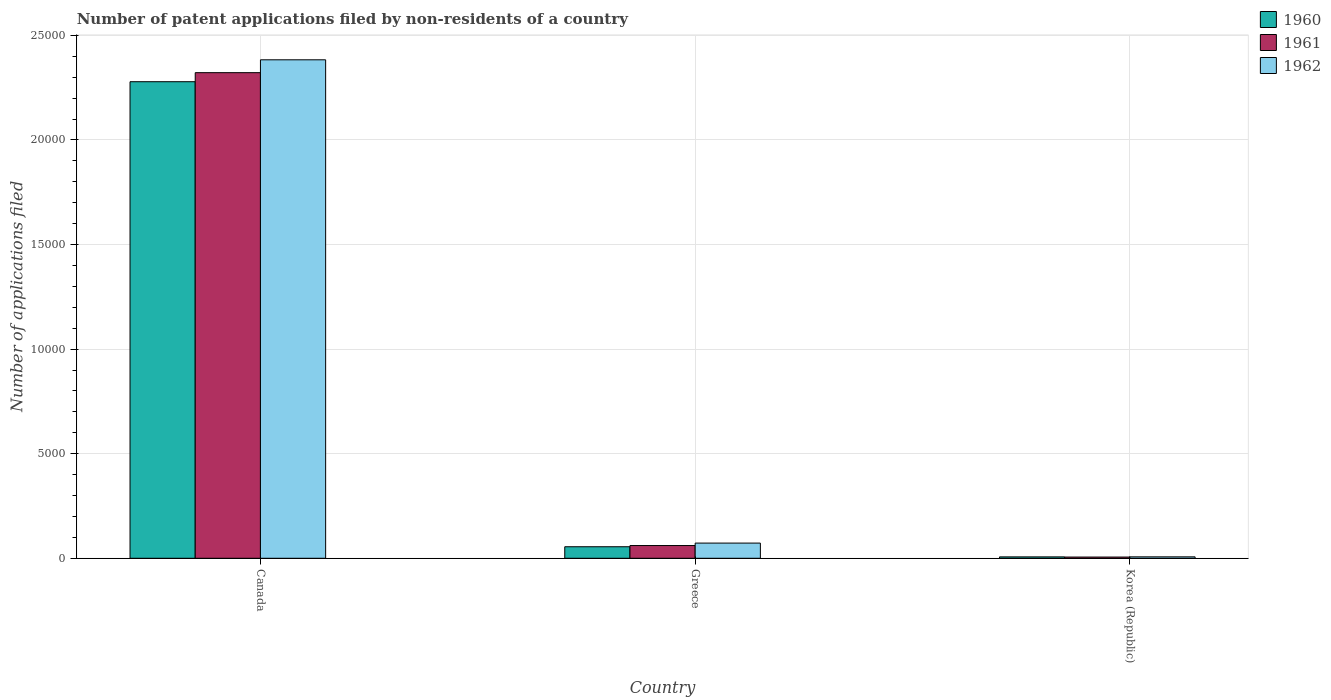How many groups of bars are there?
Your response must be concise. 3. Are the number of bars on each tick of the X-axis equal?
Your response must be concise. Yes. What is the label of the 3rd group of bars from the left?
Offer a very short reply. Korea (Republic). In how many cases, is the number of bars for a given country not equal to the number of legend labels?
Keep it short and to the point. 0. What is the number of applications filed in 1962 in Greece?
Keep it short and to the point. 726. Across all countries, what is the maximum number of applications filed in 1960?
Offer a very short reply. 2.28e+04. In which country was the number of applications filed in 1960 minimum?
Make the answer very short. Korea (Republic). What is the total number of applications filed in 1962 in the graph?
Keep it short and to the point. 2.46e+04. What is the difference between the number of applications filed in 1962 in Canada and that in Greece?
Provide a short and direct response. 2.31e+04. What is the difference between the number of applications filed in 1961 in Greece and the number of applications filed in 1960 in Canada?
Ensure brevity in your answer.  -2.22e+04. What is the average number of applications filed in 1962 per country?
Your answer should be very brief. 8209.33. What is the difference between the number of applications filed of/in 1960 and number of applications filed of/in 1961 in Canada?
Make the answer very short. -433. In how many countries, is the number of applications filed in 1961 greater than 1000?
Provide a short and direct response. 1. Is the number of applications filed in 1962 in Canada less than that in Korea (Republic)?
Your response must be concise. No. Is the difference between the number of applications filed in 1960 in Greece and Korea (Republic) greater than the difference between the number of applications filed in 1961 in Greece and Korea (Republic)?
Keep it short and to the point. No. What is the difference between the highest and the second highest number of applications filed in 1960?
Your answer should be very brief. 2.27e+04. What is the difference between the highest and the lowest number of applications filed in 1961?
Offer a very short reply. 2.32e+04. In how many countries, is the number of applications filed in 1961 greater than the average number of applications filed in 1961 taken over all countries?
Keep it short and to the point. 1. How many countries are there in the graph?
Your answer should be compact. 3. What is the difference between two consecutive major ticks on the Y-axis?
Make the answer very short. 5000. Are the values on the major ticks of Y-axis written in scientific E-notation?
Offer a very short reply. No. Does the graph contain any zero values?
Ensure brevity in your answer.  No. How many legend labels are there?
Provide a short and direct response. 3. How are the legend labels stacked?
Keep it short and to the point. Vertical. What is the title of the graph?
Offer a terse response. Number of patent applications filed by non-residents of a country. What is the label or title of the X-axis?
Provide a short and direct response. Country. What is the label or title of the Y-axis?
Your answer should be very brief. Number of applications filed. What is the Number of applications filed in 1960 in Canada?
Provide a short and direct response. 2.28e+04. What is the Number of applications filed in 1961 in Canada?
Your answer should be compact. 2.32e+04. What is the Number of applications filed in 1962 in Canada?
Ensure brevity in your answer.  2.38e+04. What is the Number of applications filed in 1960 in Greece?
Your answer should be very brief. 551. What is the Number of applications filed of 1961 in Greece?
Your answer should be compact. 609. What is the Number of applications filed in 1962 in Greece?
Your answer should be compact. 726. What is the Number of applications filed in 1960 in Korea (Republic)?
Make the answer very short. 66. What is the Number of applications filed of 1961 in Korea (Republic)?
Provide a short and direct response. 58. Across all countries, what is the maximum Number of applications filed in 1960?
Keep it short and to the point. 2.28e+04. Across all countries, what is the maximum Number of applications filed in 1961?
Give a very brief answer. 2.32e+04. Across all countries, what is the maximum Number of applications filed of 1962?
Provide a succinct answer. 2.38e+04. Across all countries, what is the minimum Number of applications filed of 1961?
Offer a very short reply. 58. Across all countries, what is the minimum Number of applications filed of 1962?
Offer a terse response. 68. What is the total Number of applications filed in 1960 in the graph?
Make the answer very short. 2.34e+04. What is the total Number of applications filed of 1961 in the graph?
Make the answer very short. 2.39e+04. What is the total Number of applications filed of 1962 in the graph?
Your answer should be compact. 2.46e+04. What is the difference between the Number of applications filed in 1960 in Canada and that in Greece?
Your answer should be compact. 2.22e+04. What is the difference between the Number of applications filed in 1961 in Canada and that in Greece?
Give a very brief answer. 2.26e+04. What is the difference between the Number of applications filed in 1962 in Canada and that in Greece?
Offer a very short reply. 2.31e+04. What is the difference between the Number of applications filed of 1960 in Canada and that in Korea (Republic)?
Your answer should be compact. 2.27e+04. What is the difference between the Number of applications filed in 1961 in Canada and that in Korea (Republic)?
Your answer should be compact. 2.32e+04. What is the difference between the Number of applications filed of 1962 in Canada and that in Korea (Republic)?
Offer a terse response. 2.38e+04. What is the difference between the Number of applications filed in 1960 in Greece and that in Korea (Republic)?
Offer a very short reply. 485. What is the difference between the Number of applications filed in 1961 in Greece and that in Korea (Republic)?
Provide a succinct answer. 551. What is the difference between the Number of applications filed in 1962 in Greece and that in Korea (Republic)?
Make the answer very short. 658. What is the difference between the Number of applications filed in 1960 in Canada and the Number of applications filed in 1961 in Greece?
Provide a short and direct response. 2.22e+04. What is the difference between the Number of applications filed in 1960 in Canada and the Number of applications filed in 1962 in Greece?
Your answer should be very brief. 2.21e+04. What is the difference between the Number of applications filed in 1961 in Canada and the Number of applications filed in 1962 in Greece?
Your answer should be compact. 2.25e+04. What is the difference between the Number of applications filed in 1960 in Canada and the Number of applications filed in 1961 in Korea (Republic)?
Offer a terse response. 2.27e+04. What is the difference between the Number of applications filed of 1960 in Canada and the Number of applications filed of 1962 in Korea (Republic)?
Keep it short and to the point. 2.27e+04. What is the difference between the Number of applications filed of 1961 in Canada and the Number of applications filed of 1962 in Korea (Republic)?
Make the answer very short. 2.32e+04. What is the difference between the Number of applications filed in 1960 in Greece and the Number of applications filed in 1961 in Korea (Republic)?
Your answer should be very brief. 493. What is the difference between the Number of applications filed in 1960 in Greece and the Number of applications filed in 1962 in Korea (Republic)?
Offer a terse response. 483. What is the difference between the Number of applications filed of 1961 in Greece and the Number of applications filed of 1962 in Korea (Republic)?
Your answer should be very brief. 541. What is the average Number of applications filed of 1960 per country?
Your answer should be compact. 7801. What is the average Number of applications filed in 1961 per country?
Ensure brevity in your answer.  7962. What is the average Number of applications filed of 1962 per country?
Your answer should be very brief. 8209.33. What is the difference between the Number of applications filed of 1960 and Number of applications filed of 1961 in Canada?
Keep it short and to the point. -433. What is the difference between the Number of applications filed of 1960 and Number of applications filed of 1962 in Canada?
Provide a short and direct response. -1048. What is the difference between the Number of applications filed in 1961 and Number of applications filed in 1962 in Canada?
Your response must be concise. -615. What is the difference between the Number of applications filed in 1960 and Number of applications filed in 1961 in Greece?
Your response must be concise. -58. What is the difference between the Number of applications filed in 1960 and Number of applications filed in 1962 in Greece?
Provide a succinct answer. -175. What is the difference between the Number of applications filed of 1961 and Number of applications filed of 1962 in Greece?
Ensure brevity in your answer.  -117. What is the difference between the Number of applications filed of 1960 and Number of applications filed of 1962 in Korea (Republic)?
Your answer should be very brief. -2. What is the difference between the Number of applications filed of 1961 and Number of applications filed of 1962 in Korea (Republic)?
Offer a terse response. -10. What is the ratio of the Number of applications filed in 1960 in Canada to that in Greece?
Offer a terse response. 41.35. What is the ratio of the Number of applications filed of 1961 in Canada to that in Greece?
Give a very brief answer. 38.13. What is the ratio of the Number of applications filed in 1962 in Canada to that in Greece?
Keep it short and to the point. 32.83. What is the ratio of the Number of applications filed of 1960 in Canada to that in Korea (Republic)?
Ensure brevity in your answer.  345.24. What is the ratio of the Number of applications filed of 1961 in Canada to that in Korea (Republic)?
Keep it short and to the point. 400.33. What is the ratio of the Number of applications filed of 1962 in Canada to that in Korea (Republic)?
Ensure brevity in your answer.  350.5. What is the ratio of the Number of applications filed in 1960 in Greece to that in Korea (Republic)?
Give a very brief answer. 8.35. What is the ratio of the Number of applications filed of 1961 in Greece to that in Korea (Republic)?
Give a very brief answer. 10.5. What is the ratio of the Number of applications filed in 1962 in Greece to that in Korea (Republic)?
Provide a short and direct response. 10.68. What is the difference between the highest and the second highest Number of applications filed in 1960?
Provide a short and direct response. 2.22e+04. What is the difference between the highest and the second highest Number of applications filed of 1961?
Your answer should be compact. 2.26e+04. What is the difference between the highest and the second highest Number of applications filed of 1962?
Offer a terse response. 2.31e+04. What is the difference between the highest and the lowest Number of applications filed of 1960?
Your response must be concise. 2.27e+04. What is the difference between the highest and the lowest Number of applications filed of 1961?
Keep it short and to the point. 2.32e+04. What is the difference between the highest and the lowest Number of applications filed of 1962?
Provide a succinct answer. 2.38e+04. 